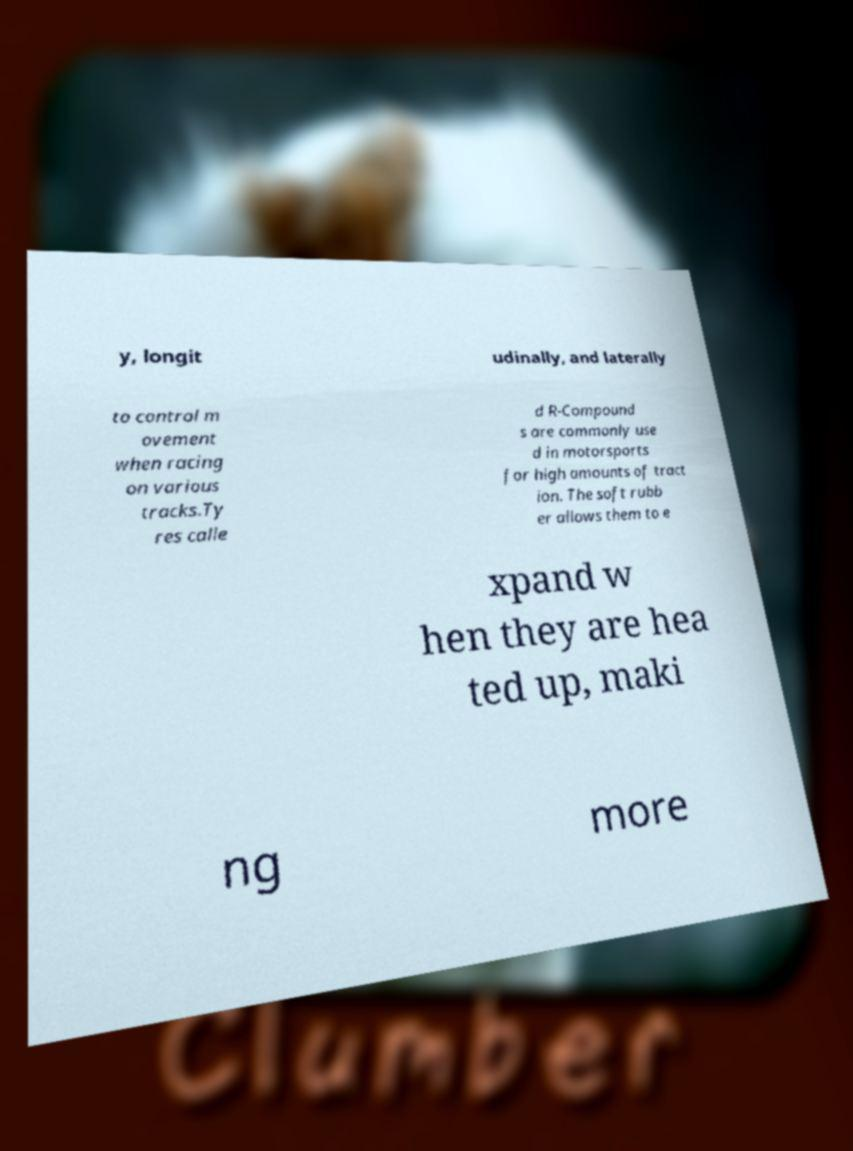Please read and relay the text visible in this image. What does it say? y, longit udinally, and laterally to control m ovement when racing on various tracks.Ty res calle d R-Compound s are commonly use d in motorsports for high amounts of tract ion. The soft rubb er allows them to e xpand w hen they are hea ted up, maki ng more 